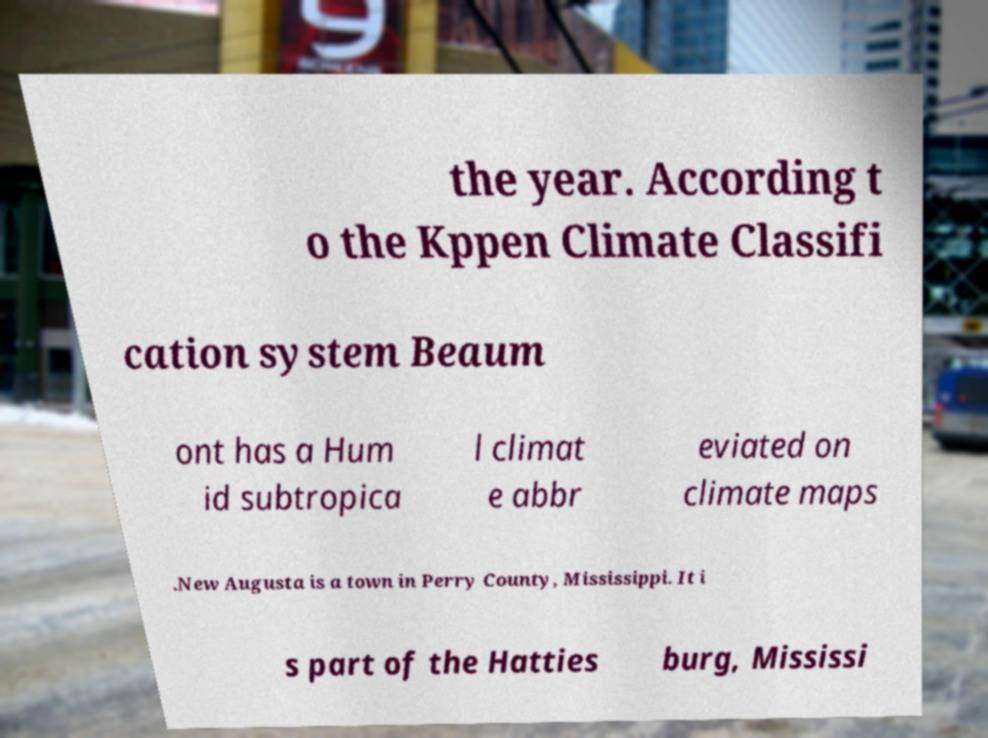Please identify and transcribe the text found in this image. the year. According t o the Kppen Climate Classifi cation system Beaum ont has a Hum id subtropica l climat e abbr eviated on climate maps .New Augusta is a town in Perry County, Mississippi. It i s part of the Hatties burg, Mississi 